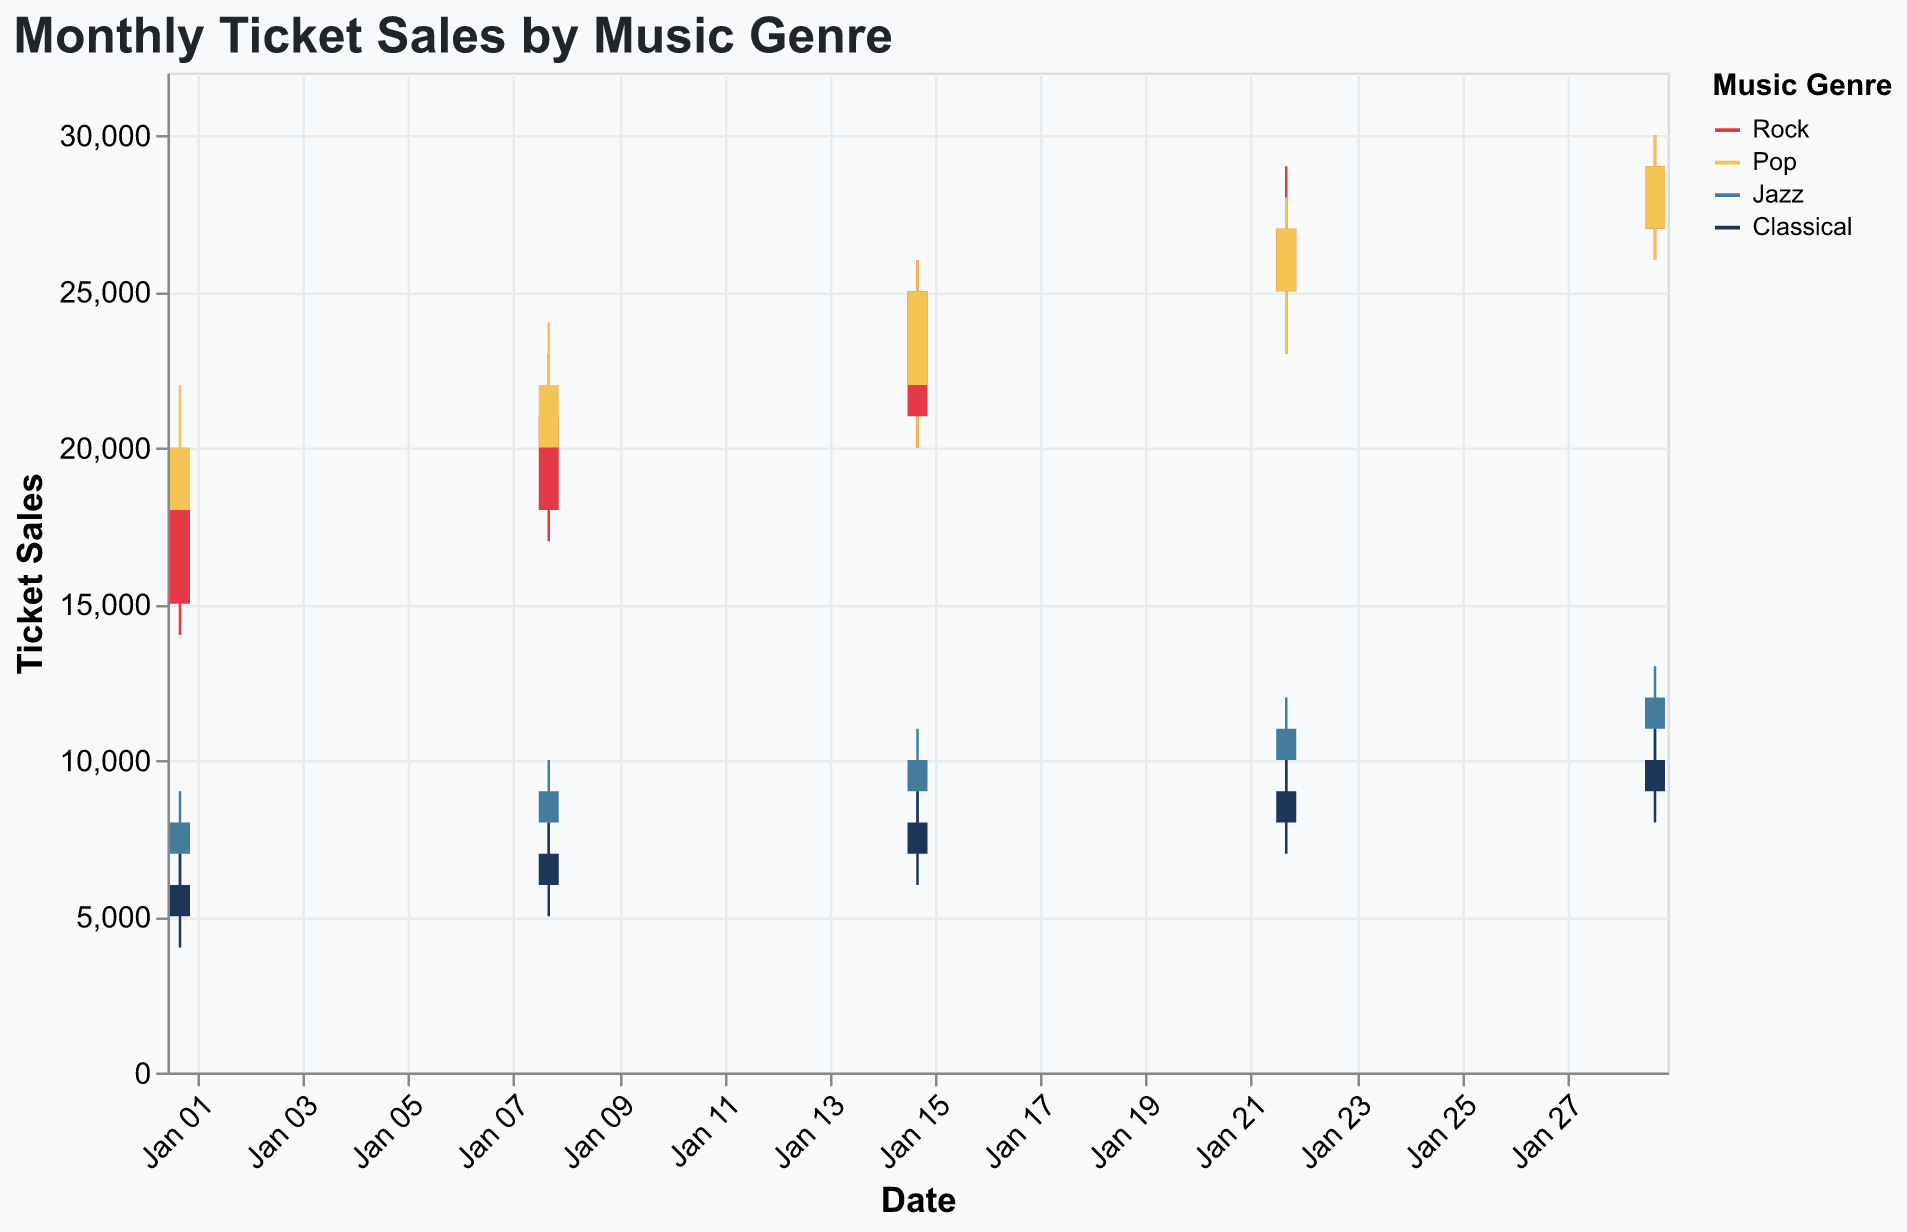What is the title of the figure? The title of the figure is prominently displayed at the top. It reads "Monthly Ticket Sales by Music Genre."
Answer: Monthly Ticket Sales by Music Genre What are the four music genres displayed in the figure? The four music genres can be identified from the legend on the right side, which lists "Rock," "Pop," "Jazz," and "Classical."
Answer: Rock, Pop, Jazz, Classical What is the highest ticket sale value for Rock in January 2023? The highest ticket sale value for Rock occurs in the week of January 29, 2023. The high value listed on that date is 30,000.
Answer: 30,000 Which genre has the smallest range of ticket sales on January 1, 2023? On January 1, 2023, Jazz has the smallest range of ticket sales. The high is 9,000 and the low is 6,000, giving a range of 3,000.
Answer: Jazz What is the difference between the highest and lowest ticket sales for Pop on January 15, 2023? For Pop on January 15, 2023, the highest ticket sale is 26,000 and the lowest is 20,000. The difference is 26,000 - 20,000 = 6,000.
Answer: 6,000 Between Rock and Classical, which genre shows a higher closing value on January 22, 2023? On January 22, 2023, Rock has a closing value of 27,000 while Classical has a closing value of 9,000. Rock has the higher closing value.
Answer: Rock How many times did the closing value for Jazz increase throughout January 2023? The closing value for Jazz is 8,000 on January 1, 9,000 on January 8, 10,000 on January 15, 11,000 on January 22, and 12,000 on January 29. It increased every week, totaling four increases.
Answer: 4 What is the average closing value for Classical in January 2023? The closing values for Classical over the weeks are 6,000, 7,000, 8,000, 9,000, and 10,000. Summing these, 6,000 + 7,000 + 8,000 + 9,000 + 10,000 = 40,000, and dividing by 5 weeks gives an average of 8,000.
Answer: 8,000 On which date did Pop see the first closing value equal to its opening value at the start of January 2023? Pop saw its first closing value equal to its opening value on January 29, 2023, where both the opening and closing values were 29,000.
Answer: January 29, 2023 